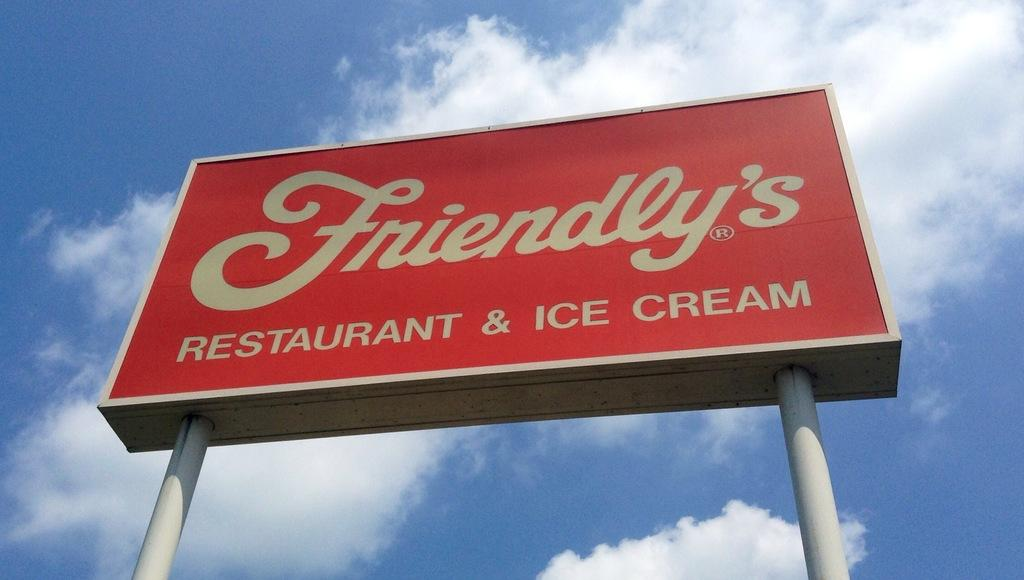<image>
Create a compact narrative representing the image presented. A Friendly's restaurant sign towers overhead in front of a blue sky. 